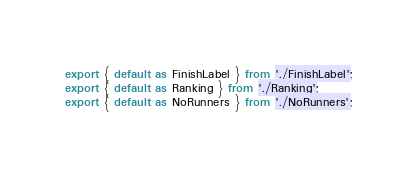Convert code to text. <code><loc_0><loc_0><loc_500><loc_500><_JavaScript_>export { default as FinishLabel } from './FinishLabel';
export { default as Ranking } from './Ranking';
export { default as NoRunners } from './NoRunners';
</code> 